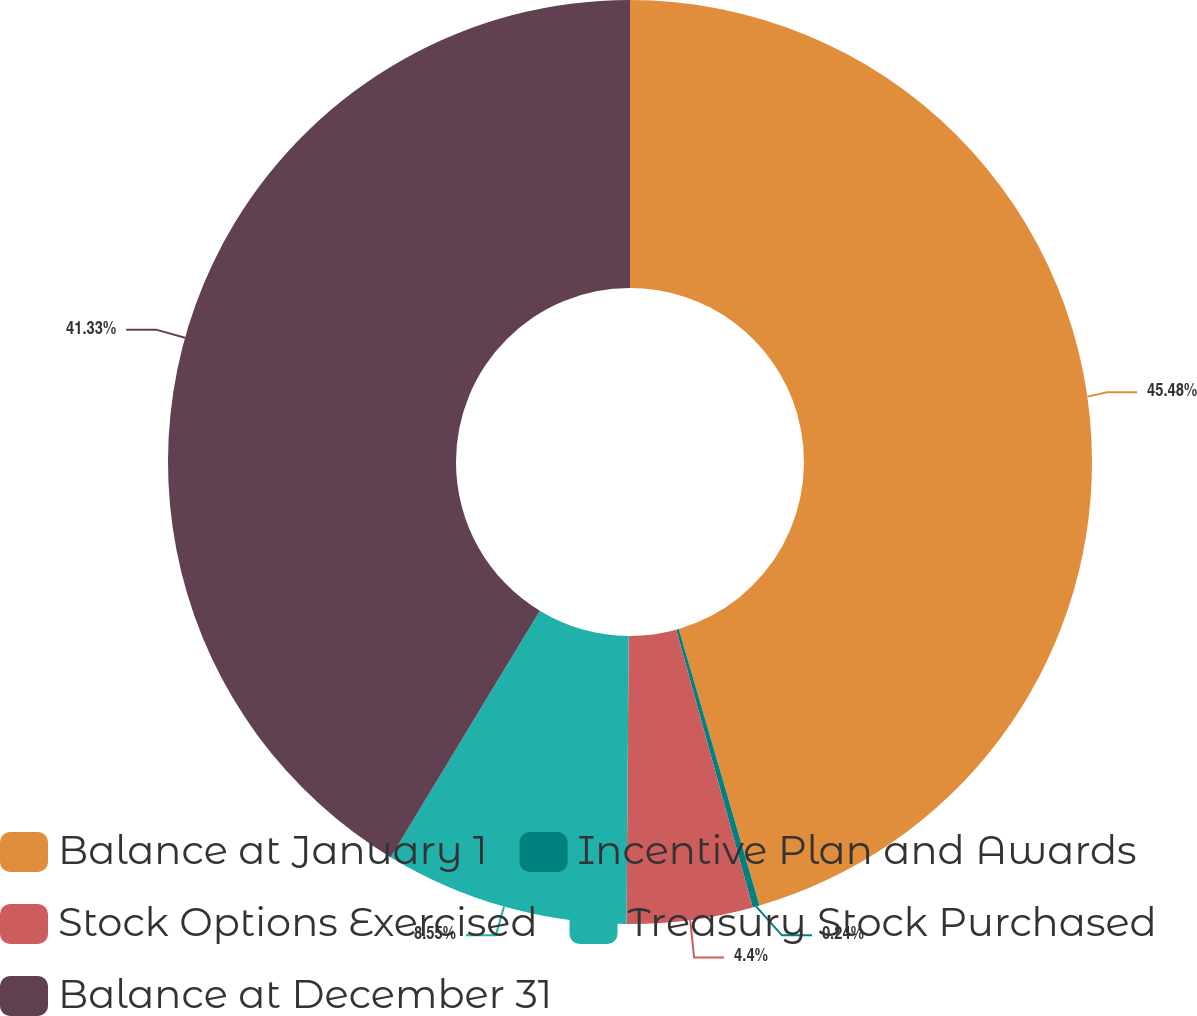Convert chart to OTSL. <chart><loc_0><loc_0><loc_500><loc_500><pie_chart><fcel>Balance at January 1<fcel>Incentive Plan and Awards<fcel>Stock Options Exercised<fcel>Treasury Stock Purchased<fcel>Balance at December 31<nl><fcel>45.48%<fcel>0.24%<fcel>4.4%<fcel>8.55%<fcel>41.33%<nl></chart> 